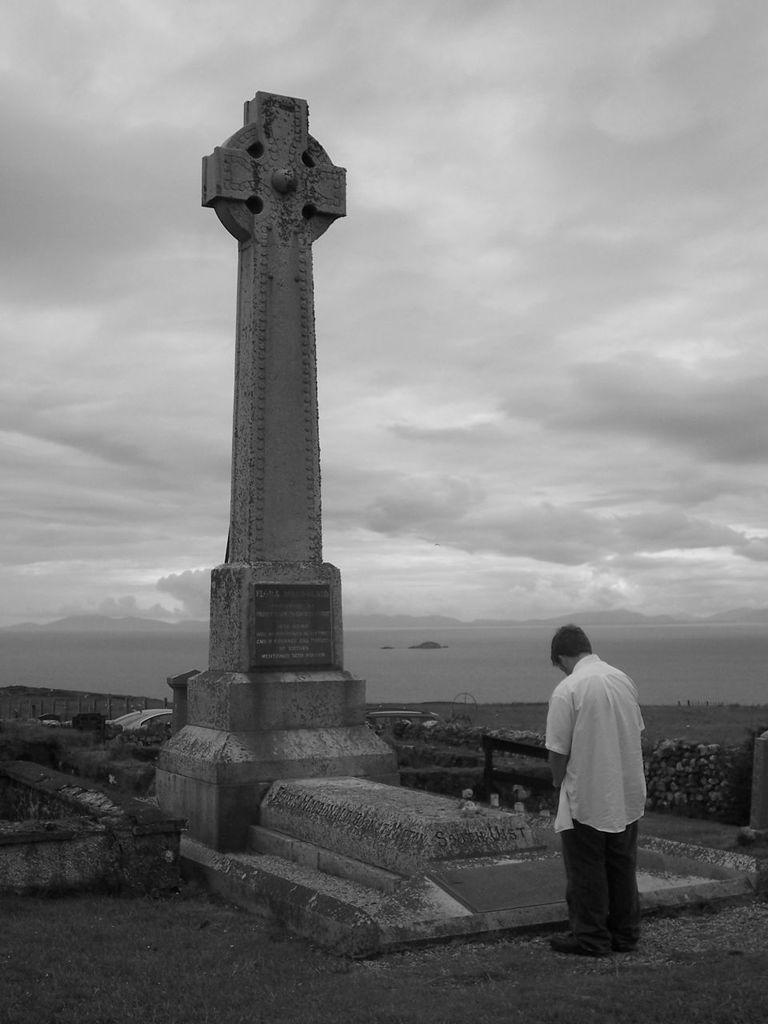Please provide a concise description of this image. In this picture we can see a person is standing in the front, there is a memorial in the middle, in the background there are some plants, we can see the sky and clouds at the top of the picture. 